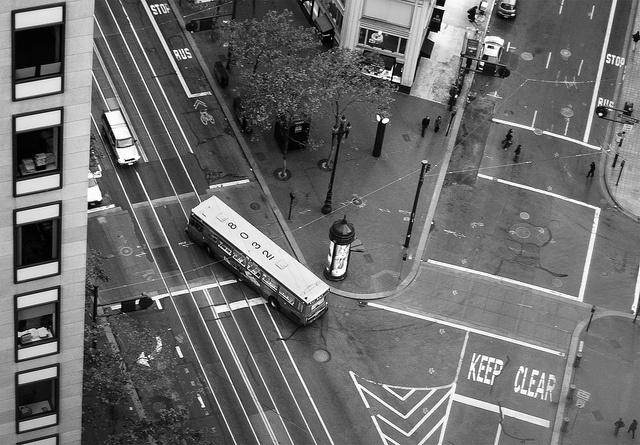Describe the objects in this image and their specific colors. I can see bus in darkgray, lightgray, black, and gray tones, truck in darkgray, white, black, and gray tones, car in darkgray, white, black, and gray tones, traffic light in darkgray, black, gray, and lightgray tones, and car in darkgray, whitesmoke, black, and gray tones in this image. 